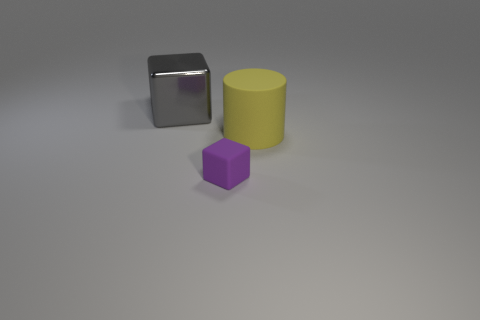Add 3 small purple cubes. How many objects exist? 6 Subtract all blocks. How many objects are left? 1 Add 2 small purple rubber cubes. How many small purple rubber cubes are left? 3 Add 1 large gray things. How many large gray things exist? 2 Subtract 0 brown cylinders. How many objects are left? 3 Subtract all cylinders. Subtract all big gray metallic objects. How many objects are left? 1 